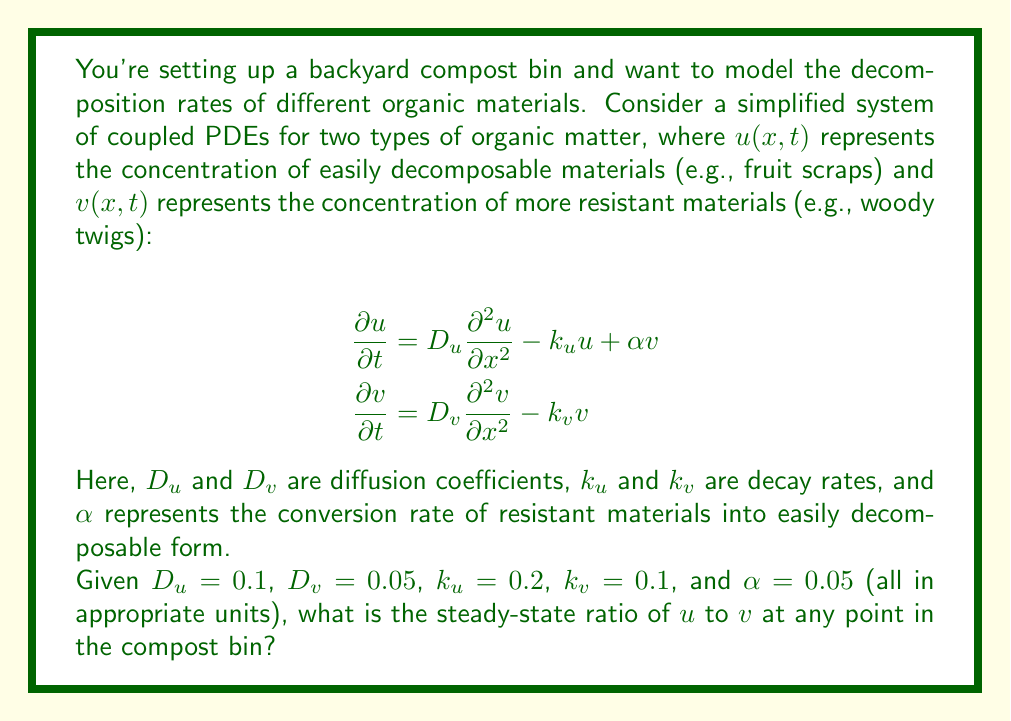Can you answer this question? To solve this problem, we need to find the steady-state solution of the system. At steady state, the concentrations don't change with time, so we set the time derivatives to zero:

$$\begin{align*}
0 &= D_u \frac{\partial^2 u}{\partial x^2} - k_u u + \alpha v \\
0 &= D_v \frac{\partial^2 v}{\partial x^2} - k_v v
\end{align*}$$

In a well-mixed compost bin, we can assume that the spatial derivatives are also zero at steady state. This simplifies our equations to:

$$\begin{align*}
0 &= -k_u u + \alpha v \\
0 &= -k_v v
\end{align*}$$

From the second equation, we can see that at steady state, $v = 0$. Substituting this into the first equation:

$$0 = -k_u u + \alpha \cdot 0 = -k_u u$$

This is only true if $u = 0$ as well.

However, this solution ($u = v = 0$) represents the long-term state where all organic matter has completely decomposed. To find a meaningful ratio of $u$ to $v$ during the composting process, we need to consider the relative rates at which $u$ and $v$ approach zero.

We can rearrange the first steady-state equation to express $u$ in terms of $v$:

$$u = \frac{\alpha v}{k_u}$$

This gives us the ratio of $u$ to $v$ at any point in the compost bin during the decomposition process:

$$\frac{u}{v} = \frac{\alpha}{k_u}$$

Substituting the given values:

$$\frac{u}{v} = \frac{0.05}{0.2} = 0.25$$
Answer: The steady-state ratio of easily decomposable materials ($u$) to resistant materials ($v$) at any point in the compost bin is 0.25 or 1:4. 